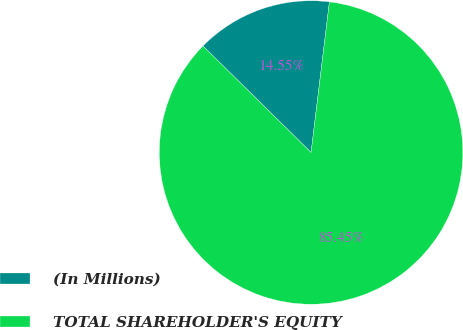<chart> <loc_0><loc_0><loc_500><loc_500><pie_chart><fcel>(In Millions)<fcel>TOTAL SHAREHOLDER'S EQUITY<nl><fcel>14.55%<fcel>85.45%<nl></chart> 